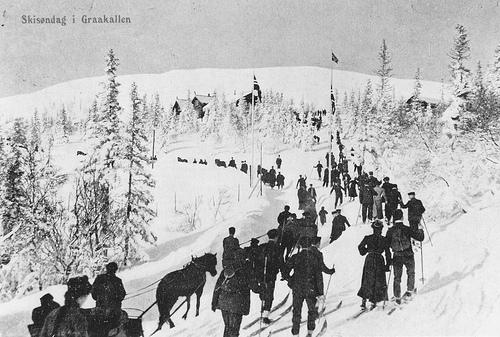Briefly summarize the primary subject and action taking place in the image. A black horse walks as people ski up a snowy hill, with trees, a flag pole, and a house in the background. Explain the core elements and activities occurring in the image in a concise manner. A black horse and skiers move along a snowy hill, surrounded by tall trees, a house, and a flag pole. Provide a brief overview of the main subjects and actions taking place in the image. A black horse walks near people skiing up a snowy hill, as tall trees, a house, and a flag pole complete the scene. Provide a concise description of the main objects and actions in the picture. A black horse walks near skiers on a snowy hill, surrounded by trees, a house, and a flag pole. Create a brief narrative describing the scene in the image. On a beautiful winter day, a black horse strolls by as people ski up a snowy hill, passing a flag pole and a house nestled among tall trees. In one sentence, depict the scene and the key activities happening in the image. The image captures a black horse walking by skiers ascending a snow-covered hill, with trees, a house, and a flag pole in the background. Compose a short statement describing the main subjects and events in the image. A black horse and skiing people share a snowy hill, accompanied by tall trees, a cozy house, and a flag pole. Mention the key elements and activities in the image in a single sentence. The image features a walking black horse, skiing people, snow-covered hill with trees, a house, and a flag pole. Give a succinct explanation of the main components and happenings in the image. The image shows a black horse and people skiing up a snowy hill, with a backdrop of trees, a house, and a flag pole. Describe the primary scene and activities occurring in the photograph. A black horse walks alongside people with skis who are ascending a snow-covered hill, with trees, a house, and a flag pole nearby. 